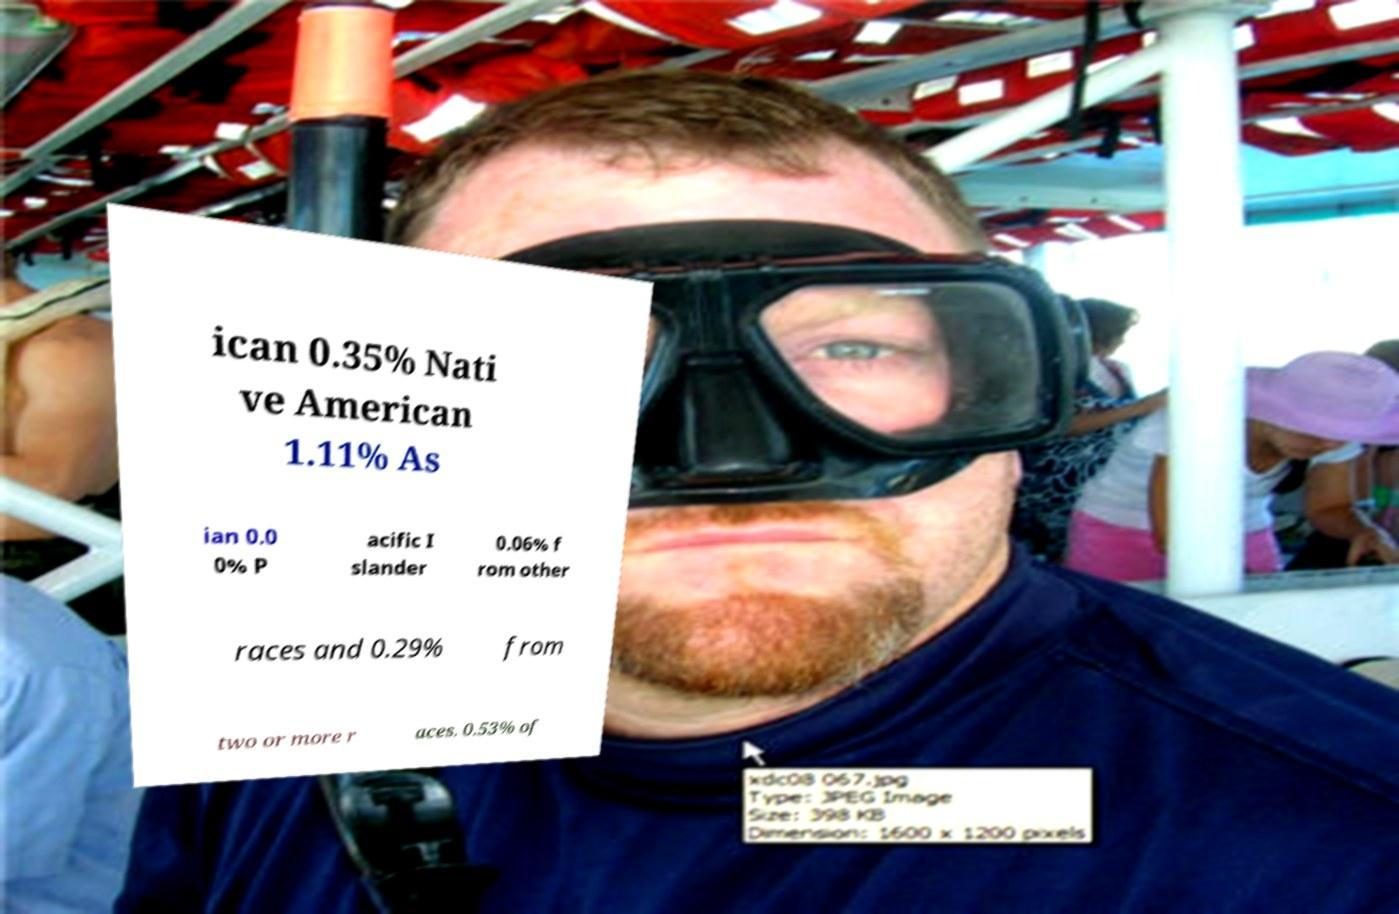What messages or text are displayed in this image? I need them in a readable, typed format. ican 0.35% Nati ve American 1.11% As ian 0.0 0% P acific I slander 0.06% f rom other races and 0.29% from two or more r aces. 0.53% of 